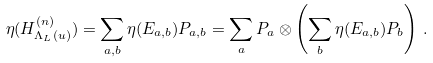Convert formula to latex. <formula><loc_0><loc_0><loc_500><loc_500>\eta ( H _ { \Lambda _ { L } ( u ) } ^ { ( n ) } ) = \sum _ { a , b } \eta ( E _ { a , b } ) P _ { a , b } = \sum _ { a } P _ { a } \otimes \left ( \sum _ { b } \eta ( E _ { a , b } ) P _ { b } \right ) \, .</formula> 